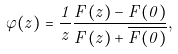<formula> <loc_0><loc_0><loc_500><loc_500>\varphi ( z ) = \frac { 1 } { z } \frac { F ( z ) - F ( 0 ) } { F ( z ) + \overline { F ( 0 ) } } ,</formula> 